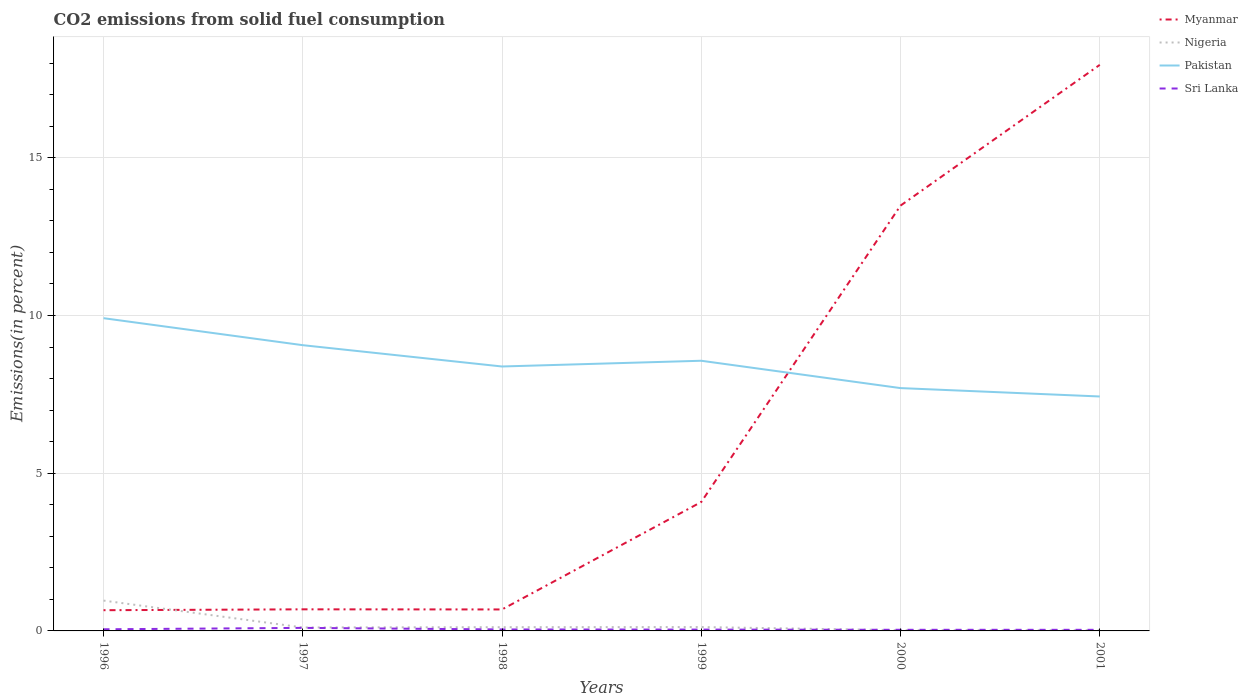How many different coloured lines are there?
Ensure brevity in your answer.  4. Across all years, what is the maximum total CO2 emitted in Nigeria?
Your answer should be very brief. 0.02. In which year was the total CO2 emitted in Sri Lanka maximum?
Your answer should be compact. 2001. What is the total total CO2 emitted in Pakistan in the graph?
Your answer should be compact. 2.22. What is the difference between the highest and the second highest total CO2 emitted in Myanmar?
Your answer should be very brief. 17.29. What is the difference between the highest and the lowest total CO2 emitted in Pakistan?
Your response must be concise. 3. How many lines are there?
Keep it short and to the point. 4. Are the values on the major ticks of Y-axis written in scientific E-notation?
Offer a terse response. No. Does the graph contain any zero values?
Make the answer very short. No. Does the graph contain grids?
Make the answer very short. Yes. Where does the legend appear in the graph?
Your response must be concise. Top right. How are the legend labels stacked?
Keep it short and to the point. Vertical. What is the title of the graph?
Keep it short and to the point. CO2 emissions from solid fuel consumption. What is the label or title of the Y-axis?
Offer a terse response. Emissions(in percent). What is the Emissions(in percent) of Myanmar in 1996?
Keep it short and to the point. 0.66. What is the Emissions(in percent) in Nigeria in 1996?
Make the answer very short. 0.96. What is the Emissions(in percent) in Pakistan in 1996?
Make the answer very short. 9.92. What is the Emissions(in percent) in Sri Lanka in 1996?
Offer a terse response. 0.05. What is the Emissions(in percent) of Myanmar in 1997?
Your answer should be compact. 0.68. What is the Emissions(in percent) in Nigeria in 1997?
Make the answer very short. 0.11. What is the Emissions(in percent) of Pakistan in 1997?
Offer a very short reply. 9.06. What is the Emissions(in percent) in Sri Lanka in 1997?
Keep it short and to the point. 0.1. What is the Emissions(in percent) of Myanmar in 1998?
Your answer should be very brief. 0.68. What is the Emissions(in percent) of Nigeria in 1998?
Provide a short and direct response. 0.12. What is the Emissions(in percent) in Pakistan in 1998?
Offer a terse response. 8.38. What is the Emissions(in percent) in Sri Lanka in 1998?
Offer a terse response. 0.05. What is the Emissions(in percent) of Myanmar in 1999?
Your response must be concise. 4.09. What is the Emissions(in percent) in Nigeria in 1999?
Your answer should be compact. 0.12. What is the Emissions(in percent) in Pakistan in 1999?
Make the answer very short. 8.57. What is the Emissions(in percent) in Sri Lanka in 1999?
Give a very brief answer. 0.04. What is the Emissions(in percent) of Myanmar in 2000?
Ensure brevity in your answer.  13.49. What is the Emissions(in percent) in Nigeria in 2000?
Keep it short and to the point. 0.02. What is the Emissions(in percent) of Pakistan in 2000?
Offer a terse response. 7.7. What is the Emissions(in percent) of Sri Lanka in 2000?
Ensure brevity in your answer.  0.04. What is the Emissions(in percent) of Myanmar in 2001?
Your answer should be very brief. 17.95. What is the Emissions(in percent) in Nigeria in 2001?
Your response must be concise. 0.02. What is the Emissions(in percent) of Pakistan in 2001?
Your answer should be very brief. 7.43. What is the Emissions(in percent) of Sri Lanka in 2001?
Give a very brief answer. 0.04. Across all years, what is the maximum Emissions(in percent) of Myanmar?
Provide a succinct answer. 17.95. Across all years, what is the maximum Emissions(in percent) of Nigeria?
Keep it short and to the point. 0.96. Across all years, what is the maximum Emissions(in percent) in Pakistan?
Make the answer very short. 9.92. Across all years, what is the maximum Emissions(in percent) in Sri Lanka?
Provide a short and direct response. 0.1. Across all years, what is the minimum Emissions(in percent) of Myanmar?
Your answer should be compact. 0.66. Across all years, what is the minimum Emissions(in percent) of Nigeria?
Your response must be concise. 0.02. Across all years, what is the minimum Emissions(in percent) in Pakistan?
Your response must be concise. 7.43. Across all years, what is the minimum Emissions(in percent) of Sri Lanka?
Ensure brevity in your answer.  0.04. What is the total Emissions(in percent) of Myanmar in the graph?
Your answer should be very brief. 37.55. What is the total Emissions(in percent) in Nigeria in the graph?
Offer a terse response. 1.36. What is the total Emissions(in percent) in Pakistan in the graph?
Your answer should be compact. 51.06. What is the total Emissions(in percent) in Sri Lanka in the graph?
Give a very brief answer. 0.31. What is the difference between the Emissions(in percent) of Myanmar in 1996 and that in 1997?
Your answer should be very brief. -0.03. What is the difference between the Emissions(in percent) of Nigeria in 1996 and that in 1997?
Offer a very short reply. 0.85. What is the difference between the Emissions(in percent) in Pakistan in 1996 and that in 1997?
Make the answer very short. 0.86. What is the difference between the Emissions(in percent) in Sri Lanka in 1996 and that in 1997?
Keep it short and to the point. -0.04. What is the difference between the Emissions(in percent) of Myanmar in 1996 and that in 1998?
Offer a very short reply. -0.02. What is the difference between the Emissions(in percent) of Nigeria in 1996 and that in 1998?
Make the answer very short. 0.84. What is the difference between the Emissions(in percent) of Pakistan in 1996 and that in 1998?
Provide a succinct answer. 1.53. What is the difference between the Emissions(in percent) in Sri Lanka in 1996 and that in 1998?
Your response must be concise. 0.01. What is the difference between the Emissions(in percent) of Myanmar in 1996 and that in 1999?
Ensure brevity in your answer.  -3.43. What is the difference between the Emissions(in percent) of Nigeria in 1996 and that in 1999?
Your answer should be compact. 0.84. What is the difference between the Emissions(in percent) of Pakistan in 1996 and that in 1999?
Offer a very short reply. 1.35. What is the difference between the Emissions(in percent) in Sri Lanka in 1996 and that in 1999?
Ensure brevity in your answer.  0.01. What is the difference between the Emissions(in percent) in Myanmar in 1996 and that in 2000?
Provide a succinct answer. -12.83. What is the difference between the Emissions(in percent) in Nigeria in 1996 and that in 2000?
Your answer should be compact. 0.94. What is the difference between the Emissions(in percent) in Pakistan in 1996 and that in 2000?
Provide a short and direct response. 2.22. What is the difference between the Emissions(in percent) of Sri Lanka in 1996 and that in 2000?
Offer a very short reply. 0.02. What is the difference between the Emissions(in percent) in Myanmar in 1996 and that in 2001?
Your answer should be compact. -17.29. What is the difference between the Emissions(in percent) of Nigeria in 1996 and that in 2001?
Provide a short and direct response. 0.94. What is the difference between the Emissions(in percent) of Pakistan in 1996 and that in 2001?
Make the answer very short. 2.48. What is the difference between the Emissions(in percent) in Sri Lanka in 1996 and that in 2001?
Offer a very short reply. 0.02. What is the difference between the Emissions(in percent) in Myanmar in 1997 and that in 1998?
Your response must be concise. 0. What is the difference between the Emissions(in percent) in Nigeria in 1997 and that in 1998?
Your answer should be compact. -0.01. What is the difference between the Emissions(in percent) in Pakistan in 1997 and that in 1998?
Your answer should be very brief. 0.68. What is the difference between the Emissions(in percent) of Sri Lanka in 1997 and that in 1998?
Offer a very short reply. 0.05. What is the difference between the Emissions(in percent) of Myanmar in 1997 and that in 1999?
Give a very brief answer. -3.4. What is the difference between the Emissions(in percent) of Nigeria in 1997 and that in 1999?
Your response must be concise. -0.01. What is the difference between the Emissions(in percent) of Pakistan in 1997 and that in 1999?
Provide a succinct answer. 0.49. What is the difference between the Emissions(in percent) in Sri Lanka in 1997 and that in 1999?
Provide a succinct answer. 0.05. What is the difference between the Emissions(in percent) of Myanmar in 1997 and that in 2000?
Provide a short and direct response. -12.8. What is the difference between the Emissions(in percent) of Nigeria in 1997 and that in 2000?
Your answer should be compact. 0.09. What is the difference between the Emissions(in percent) of Pakistan in 1997 and that in 2000?
Offer a terse response. 1.36. What is the difference between the Emissions(in percent) of Sri Lanka in 1997 and that in 2000?
Your answer should be very brief. 0.06. What is the difference between the Emissions(in percent) in Myanmar in 1997 and that in 2001?
Your answer should be compact. -17.26. What is the difference between the Emissions(in percent) in Nigeria in 1997 and that in 2001?
Your answer should be very brief. 0.09. What is the difference between the Emissions(in percent) in Pakistan in 1997 and that in 2001?
Give a very brief answer. 1.63. What is the difference between the Emissions(in percent) of Sri Lanka in 1997 and that in 2001?
Provide a short and direct response. 0.06. What is the difference between the Emissions(in percent) in Myanmar in 1998 and that in 1999?
Make the answer very short. -3.41. What is the difference between the Emissions(in percent) in Nigeria in 1998 and that in 1999?
Provide a succinct answer. -0. What is the difference between the Emissions(in percent) of Pakistan in 1998 and that in 1999?
Your answer should be compact. -0.18. What is the difference between the Emissions(in percent) of Sri Lanka in 1998 and that in 1999?
Offer a terse response. 0. What is the difference between the Emissions(in percent) of Myanmar in 1998 and that in 2000?
Offer a terse response. -12.81. What is the difference between the Emissions(in percent) in Nigeria in 1998 and that in 2000?
Ensure brevity in your answer.  0.1. What is the difference between the Emissions(in percent) of Pakistan in 1998 and that in 2000?
Your answer should be very brief. 0.69. What is the difference between the Emissions(in percent) in Sri Lanka in 1998 and that in 2000?
Keep it short and to the point. 0.01. What is the difference between the Emissions(in percent) in Myanmar in 1998 and that in 2001?
Your answer should be very brief. -17.27. What is the difference between the Emissions(in percent) of Nigeria in 1998 and that in 2001?
Make the answer very short. 0.1. What is the difference between the Emissions(in percent) in Pakistan in 1998 and that in 2001?
Your answer should be very brief. 0.95. What is the difference between the Emissions(in percent) of Sri Lanka in 1998 and that in 2001?
Provide a succinct answer. 0.01. What is the difference between the Emissions(in percent) in Myanmar in 1999 and that in 2000?
Provide a succinct answer. -9.4. What is the difference between the Emissions(in percent) of Nigeria in 1999 and that in 2000?
Your answer should be compact. 0.1. What is the difference between the Emissions(in percent) of Pakistan in 1999 and that in 2000?
Ensure brevity in your answer.  0.87. What is the difference between the Emissions(in percent) of Sri Lanka in 1999 and that in 2000?
Your response must be concise. 0.01. What is the difference between the Emissions(in percent) of Myanmar in 1999 and that in 2001?
Make the answer very short. -13.86. What is the difference between the Emissions(in percent) of Nigeria in 1999 and that in 2001?
Offer a very short reply. 0.1. What is the difference between the Emissions(in percent) in Pakistan in 1999 and that in 2001?
Provide a succinct answer. 1.13. What is the difference between the Emissions(in percent) in Sri Lanka in 1999 and that in 2001?
Your response must be concise. 0.01. What is the difference between the Emissions(in percent) in Myanmar in 2000 and that in 2001?
Provide a short and direct response. -4.46. What is the difference between the Emissions(in percent) of Nigeria in 2000 and that in 2001?
Make the answer very short. 0. What is the difference between the Emissions(in percent) of Pakistan in 2000 and that in 2001?
Provide a short and direct response. 0.27. What is the difference between the Emissions(in percent) of Sri Lanka in 2000 and that in 2001?
Your answer should be very brief. 0. What is the difference between the Emissions(in percent) in Myanmar in 1996 and the Emissions(in percent) in Nigeria in 1997?
Provide a short and direct response. 0.55. What is the difference between the Emissions(in percent) of Myanmar in 1996 and the Emissions(in percent) of Pakistan in 1997?
Your response must be concise. -8.4. What is the difference between the Emissions(in percent) of Myanmar in 1996 and the Emissions(in percent) of Sri Lanka in 1997?
Offer a very short reply. 0.56. What is the difference between the Emissions(in percent) of Nigeria in 1996 and the Emissions(in percent) of Pakistan in 1997?
Provide a succinct answer. -8.1. What is the difference between the Emissions(in percent) of Nigeria in 1996 and the Emissions(in percent) of Sri Lanka in 1997?
Your response must be concise. 0.87. What is the difference between the Emissions(in percent) of Pakistan in 1996 and the Emissions(in percent) of Sri Lanka in 1997?
Offer a very short reply. 9.82. What is the difference between the Emissions(in percent) in Myanmar in 1996 and the Emissions(in percent) in Nigeria in 1998?
Your answer should be compact. 0.54. What is the difference between the Emissions(in percent) of Myanmar in 1996 and the Emissions(in percent) of Pakistan in 1998?
Give a very brief answer. -7.73. What is the difference between the Emissions(in percent) of Myanmar in 1996 and the Emissions(in percent) of Sri Lanka in 1998?
Offer a terse response. 0.61. What is the difference between the Emissions(in percent) in Nigeria in 1996 and the Emissions(in percent) in Pakistan in 1998?
Offer a very short reply. -7.42. What is the difference between the Emissions(in percent) of Nigeria in 1996 and the Emissions(in percent) of Sri Lanka in 1998?
Give a very brief answer. 0.91. What is the difference between the Emissions(in percent) in Pakistan in 1996 and the Emissions(in percent) in Sri Lanka in 1998?
Keep it short and to the point. 9.87. What is the difference between the Emissions(in percent) in Myanmar in 1996 and the Emissions(in percent) in Nigeria in 1999?
Give a very brief answer. 0.53. What is the difference between the Emissions(in percent) in Myanmar in 1996 and the Emissions(in percent) in Pakistan in 1999?
Your response must be concise. -7.91. What is the difference between the Emissions(in percent) of Myanmar in 1996 and the Emissions(in percent) of Sri Lanka in 1999?
Ensure brevity in your answer.  0.61. What is the difference between the Emissions(in percent) of Nigeria in 1996 and the Emissions(in percent) of Pakistan in 1999?
Provide a succinct answer. -7.6. What is the difference between the Emissions(in percent) of Nigeria in 1996 and the Emissions(in percent) of Sri Lanka in 1999?
Your answer should be very brief. 0.92. What is the difference between the Emissions(in percent) in Pakistan in 1996 and the Emissions(in percent) in Sri Lanka in 1999?
Your answer should be very brief. 9.87. What is the difference between the Emissions(in percent) in Myanmar in 1996 and the Emissions(in percent) in Nigeria in 2000?
Offer a terse response. 0.63. What is the difference between the Emissions(in percent) in Myanmar in 1996 and the Emissions(in percent) in Pakistan in 2000?
Ensure brevity in your answer.  -7.04. What is the difference between the Emissions(in percent) of Myanmar in 1996 and the Emissions(in percent) of Sri Lanka in 2000?
Provide a short and direct response. 0.62. What is the difference between the Emissions(in percent) of Nigeria in 1996 and the Emissions(in percent) of Pakistan in 2000?
Your answer should be very brief. -6.74. What is the difference between the Emissions(in percent) of Nigeria in 1996 and the Emissions(in percent) of Sri Lanka in 2000?
Give a very brief answer. 0.93. What is the difference between the Emissions(in percent) in Pakistan in 1996 and the Emissions(in percent) in Sri Lanka in 2000?
Your answer should be very brief. 9.88. What is the difference between the Emissions(in percent) in Myanmar in 1996 and the Emissions(in percent) in Nigeria in 2001?
Your response must be concise. 0.63. What is the difference between the Emissions(in percent) in Myanmar in 1996 and the Emissions(in percent) in Pakistan in 2001?
Your answer should be compact. -6.78. What is the difference between the Emissions(in percent) of Myanmar in 1996 and the Emissions(in percent) of Sri Lanka in 2001?
Offer a very short reply. 0.62. What is the difference between the Emissions(in percent) in Nigeria in 1996 and the Emissions(in percent) in Pakistan in 2001?
Keep it short and to the point. -6.47. What is the difference between the Emissions(in percent) of Nigeria in 1996 and the Emissions(in percent) of Sri Lanka in 2001?
Provide a short and direct response. 0.93. What is the difference between the Emissions(in percent) in Pakistan in 1996 and the Emissions(in percent) in Sri Lanka in 2001?
Provide a succinct answer. 9.88. What is the difference between the Emissions(in percent) of Myanmar in 1997 and the Emissions(in percent) of Nigeria in 1998?
Ensure brevity in your answer.  0.57. What is the difference between the Emissions(in percent) of Myanmar in 1997 and the Emissions(in percent) of Pakistan in 1998?
Keep it short and to the point. -7.7. What is the difference between the Emissions(in percent) of Myanmar in 1997 and the Emissions(in percent) of Sri Lanka in 1998?
Your response must be concise. 0.64. What is the difference between the Emissions(in percent) of Nigeria in 1997 and the Emissions(in percent) of Pakistan in 1998?
Provide a succinct answer. -8.27. What is the difference between the Emissions(in percent) of Nigeria in 1997 and the Emissions(in percent) of Sri Lanka in 1998?
Make the answer very short. 0.06. What is the difference between the Emissions(in percent) in Pakistan in 1997 and the Emissions(in percent) in Sri Lanka in 1998?
Keep it short and to the point. 9.01. What is the difference between the Emissions(in percent) in Myanmar in 1997 and the Emissions(in percent) in Nigeria in 1999?
Keep it short and to the point. 0.56. What is the difference between the Emissions(in percent) in Myanmar in 1997 and the Emissions(in percent) in Pakistan in 1999?
Give a very brief answer. -7.88. What is the difference between the Emissions(in percent) in Myanmar in 1997 and the Emissions(in percent) in Sri Lanka in 1999?
Ensure brevity in your answer.  0.64. What is the difference between the Emissions(in percent) of Nigeria in 1997 and the Emissions(in percent) of Pakistan in 1999?
Offer a very short reply. -8.46. What is the difference between the Emissions(in percent) in Nigeria in 1997 and the Emissions(in percent) in Sri Lanka in 1999?
Your answer should be very brief. 0.07. What is the difference between the Emissions(in percent) in Pakistan in 1997 and the Emissions(in percent) in Sri Lanka in 1999?
Your response must be concise. 9.02. What is the difference between the Emissions(in percent) in Myanmar in 1997 and the Emissions(in percent) in Nigeria in 2000?
Provide a succinct answer. 0.66. What is the difference between the Emissions(in percent) of Myanmar in 1997 and the Emissions(in percent) of Pakistan in 2000?
Ensure brevity in your answer.  -7.01. What is the difference between the Emissions(in percent) of Myanmar in 1997 and the Emissions(in percent) of Sri Lanka in 2000?
Make the answer very short. 0.65. What is the difference between the Emissions(in percent) in Nigeria in 1997 and the Emissions(in percent) in Pakistan in 2000?
Ensure brevity in your answer.  -7.59. What is the difference between the Emissions(in percent) of Nigeria in 1997 and the Emissions(in percent) of Sri Lanka in 2000?
Ensure brevity in your answer.  0.07. What is the difference between the Emissions(in percent) of Pakistan in 1997 and the Emissions(in percent) of Sri Lanka in 2000?
Your answer should be very brief. 9.02. What is the difference between the Emissions(in percent) in Myanmar in 1997 and the Emissions(in percent) in Nigeria in 2001?
Offer a terse response. 0.66. What is the difference between the Emissions(in percent) of Myanmar in 1997 and the Emissions(in percent) of Pakistan in 2001?
Provide a short and direct response. -6.75. What is the difference between the Emissions(in percent) in Myanmar in 1997 and the Emissions(in percent) in Sri Lanka in 2001?
Provide a short and direct response. 0.65. What is the difference between the Emissions(in percent) of Nigeria in 1997 and the Emissions(in percent) of Pakistan in 2001?
Keep it short and to the point. -7.32. What is the difference between the Emissions(in percent) in Nigeria in 1997 and the Emissions(in percent) in Sri Lanka in 2001?
Offer a very short reply. 0.07. What is the difference between the Emissions(in percent) in Pakistan in 1997 and the Emissions(in percent) in Sri Lanka in 2001?
Provide a succinct answer. 9.02. What is the difference between the Emissions(in percent) of Myanmar in 1998 and the Emissions(in percent) of Nigeria in 1999?
Offer a terse response. 0.56. What is the difference between the Emissions(in percent) of Myanmar in 1998 and the Emissions(in percent) of Pakistan in 1999?
Provide a succinct answer. -7.89. What is the difference between the Emissions(in percent) of Myanmar in 1998 and the Emissions(in percent) of Sri Lanka in 1999?
Provide a succinct answer. 0.64. What is the difference between the Emissions(in percent) in Nigeria in 1998 and the Emissions(in percent) in Pakistan in 1999?
Your answer should be very brief. -8.45. What is the difference between the Emissions(in percent) of Nigeria in 1998 and the Emissions(in percent) of Sri Lanka in 1999?
Your response must be concise. 0.08. What is the difference between the Emissions(in percent) of Pakistan in 1998 and the Emissions(in percent) of Sri Lanka in 1999?
Your answer should be very brief. 8.34. What is the difference between the Emissions(in percent) in Myanmar in 1998 and the Emissions(in percent) in Nigeria in 2000?
Your answer should be very brief. 0.66. What is the difference between the Emissions(in percent) of Myanmar in 1998 and the Emissions(in percent) of Pakistan in 2000?
Offer a very short reply. -7.02. What is the difference between the Emissions(in percent) in Myanmar in 1998 and the Emissions(in percent) in Sri Lanka in 2000?
Your answer should be compact. 0.65. What is the difference between the Emissions(in percent) of Nigeria in 1998 and the Emissions(in percent) of Pakistan in 2000?
Make the answer very short. -7.58. What is the difference between the Emissions(in percent) in Nigeria in 1998 and the Emissions(in percent) in Sri Lanka in 2000?
Your answer should be very brief. 0.08. What is the difference between the Emissions(in percent) in Pakistan in 1998 and the Emissions(in percent) in Sri Lanka in 2000?
Make the answer very short. 8.35. What is the difference between the Emissions(in percent) in Myanmar in 1998 and the Emissions(in percent) in Nigeria in 2001?
Offer a terse response. 0.66. What is the difference between the Emissions(in percent) of Myanmar in 1998 and the Emissions(in percent) of Pakistan in 2001?
Ensure brevity in your answer.  -6.75. What is the difference between the Emissions(in percent) in Myanmar in 1998 and the Emissions(in percent) in Sri Lanka in 2001?
Offer a terse response. 0.65. What is the difference between the Emissions(in percent) in Nigeria in 1998 and the Emissions(in percent) in Pakistan in 2001?
Offer a very short reply. -7.31. What is the difference between the Emissions(in percent) in Nigeria in 1998 and the Emissions(in percent) in Sri Lanka in 2001?
Give a very brief answer. 0.08. What is the difference between the Emissions(in percent) in Pakistan in 1998 and the Emissions(in percent) in Sri Lanka in 2001?
Keep it short and to the point. 8.35. What is the difference between the Emissions(in percent) of Myanmar in 1999 and the Emissions(in percent) of Nigeria in 2000?
Provide a short and direct response. 4.07. What is the difference between the Emissions(in percent) of Myanmar in 1999 and the Emissions(in percent) of Pakistan in 2000?
Offer a very short reply. -3.61. What is the difference between the Emissions(in percent) of Myanmar in 1999 and the Emissions(in percent) of Sri Lanka in 2000?
Offer a very short reply. 4.05. What is the difference between the Emissions(in percent) in Nigeria in 1999 and the Emissions(in percent) in Pakistan in 2000?
Offer a terse response. -7.58. What is the difference between the Emissions(in percent) in Nigeria in 1999 and the Emissions(in percent) in Sri Lanka in 2000?
Make the answer very short. 0.09. What is the difference between the Emissions(in percent) of Pakistan in 1999 and the Emissions(in percent) of Sri Lanka in 2000?
Provide a succinct answer. 8.53. What is the difference between the Emissions(in percent) in Myanmar in 1999 and the Emissions(in percent) in Nigeria in 2001?
Provide a short and direct response. 4.07. What is the difference between the Emissions(in percent) in Myanmar in 1999 and the Emissions(in percent) in Pakistan in 2001?
Keep it short and to the point. -3.35. What is the difference between the Emissions(in percent) of Myanmar in 1999 and the Emissions(in percent) of Sri Lanka in 2001?
Your answer should be compact. 4.05. What is the difference between the Emissions(in percent) in Nigeria in 1999 and the Emissions(in percent) in Pakistan in 2001?
Make the answer very short. -7.31. What is the difference between the Emissions(in percent) in Nigeria in 1999 and the Emissions(in percent) in Sri Lanka in 2001?
Keep it short and to the point. 0.09. What is the difference between the Emissions(in percent) of Pakistan in 1999 and the Emissions(in percent) of Sri Lanka in 2001?
Give a very brief answer. 8.53. What is the difference between the Emissions(in percent) in Myanmar in 2000 and the Emissions(in percent) in Nigeria in 2001?
Provide a succinct answer. 13.46. What is the difference between the Emissions(in percent) in Myanmar in 2000 and the Emissions(in percent) in Pakistan in 2001?
Your answer should be compact. 6.05. What is the difference between the Emissions(in percent) in Myanmar in 2000 and the Emissions(in percent) in Sri Lanka in 2001?
Provide a short and direct response. 13.45. What is the difference between the Emissions(in percent) of Nigeria in 2000 and the Emissions(in percent) of Pakistan in 2001?
Your answer should be compact. -7.41. What is the difference between the Emissions(in percent) in Nigeria in 2000 and the Emissions(in percent) in Sri Lanka in 2001?
Offer a very short reply. -0.01. What is the difference between the Emissions(in percent) in Pakistan in 2000 and the Emissions(in percent) in Sri Lanka in 2001?
Your response must be concise. 7.66. What is the average Emissions(in percent) of Myanmar per year?
Provide a short and direct response. 6.26. What is the average Emissions(in percent) in Nigeria per year?
Your answer should be very brief. 0.23. What is the average Emissions(in percent) of Pakistan per year?
Give a very brief answer. 8.51. What is the average Emissions(in percent) in Sri Lanka per year?
Keep it short and to the point. 0.05. In the year 1996, what is the difference between the Emissions(in percent) of Myanmar and Emissions(in percent) of Nigeria?
Offer a terse response. -0.3. In the year 1996, what is the difference between the Emissions(in percent) of Myanmar and Emissions(in percent) of Pakistan?
Provide a short and direct response. -9.26. In the year 1996, what is the difference between the Emissions(in percent) of Myanmar and Emissions(in percent) of Sri Lanka?
Offer a very short reply. 0.6. In the year 1996, what is the difference between the Emissions(in percent) of Nigeria and Emissions(in percent) of Pakistan?
Make the answer very short. -8.95. In the year 1996, what is the difference between the Emissions(in percent) in Nigeria and Emissions(in percent) in Sri Lanka?
Your answer should be very brief. 0.91. In the year 1996, what is the difference between the Emissions(in percent) of Pakistan and Emissions(in percent) of Sri Lanka?
Make the answer very short. 9.86. In the year 1997, what is the difference between the Emissions(in percent) in Myanmar and Emissions(in percent) in Nigeria?
Your answer should be very brief. 0.58. In the year 1997, what is the difference between the Emissions(in percent) of Myanmar and Emissions(in percent) of Pakistan?
Provide a short and direct response. -8.38. In the year 1997, what is the difference between the Emissions(in percent) in Myanmar and Emissions(in percent) in Sri Lanka?
Your answer should be very brief. 0.59. In the year 1997, what is the difference between the Emissions(in percent) in Nigeria and Emissions(in percent) in Pakistan?
Your response must be concise. -8.95. In the year 1997, what is the difference between the Emissions(in percent) in Nigeria and Emissions(in percent) in Sri Lanka?
Offer a very short reply. 0.01. In the year 1997, what is the difference between the Emissions(in percent) in Pakistan and Emissions(in percent) in Sri Lanka?
Keep it short and to the point. 8.96. In the year 1998, what is the difference between the Emissions(in percent) of Myanmar and Emissions(in percent) of Nigeria?
Your answer should be very brief. 0.56. In the year 1998, what is the difference between the Emissions(in percent) of Myanmar and Emissions(in percent) of Pakistan?
Offer a very short reply. -7.7. In the year 1998, what is the difference between the Emissions(in percent) in Myanmar and Emissions(in percent) in Sri Lanka?
Offer a very short reply. 0.63. In the year 1998, what is the difference between the Emissions(in percent) of Nigeria and Emissions(in percent) of Pakistan?
Your response must be concise. -8.27. In the year 1998, what is the difference between the Emissions(in percent) in Nigeria and Emissions(in percent) in Sri Lanka?
Give a very brief answer. 0.07. In the year 1998, what is the difference between the Emissions(in percent) of Pakistan and Emissions(in percent) of Sri Lanka?
Offer a terse response. 8.34. In the year 1999, what is the difference between the Emissions(in percent) of Myanmar and Emissions(in percent) of Nigeria?
Offer a very short reply. 3.97. In the year 1999, what is the difference between the Emissions(in percent) of Myanmar and Emissions(in percent) of Pakistan?
Keep it short and to the point. -4.48. In the year 1999, what is the difference between the Emissions(in percent) in Myanmar and Emissions(in percent) in Sri Lanka?
Give a very brief answer. 4.05. In the year 1999, what is the difference between the Emissions(in percent) of Nigeria and Emissions(in percent) of Pakistan?
Your answer should be very brief. -8.44. In the year 1999, what is the difference between the Emissions(in percent) of Nigeria and Emissions(in percent) of Sri Lanka?
Offer a very short reply. 0.08. In the year 1999, what is the difference between the Emissions(in percent) in Pakistan and Emissions(in percent) in Sri Lanka?
Your answer should be very brief. 8.52. In the year 2000, what is the difference between the Emissions(in percent) of Myanmar and Emissions(in percent) of Nigeria?
Give a very brief answer. 13.46. In the year 2000, what is the difference between the Emissions(in percent) in Myanmar and Emissions(in percent) in Pakistan?
Offer a terse response. 5.79. In the year 2000, what is the difference between the Emissions(in percent) of Myanmar and Emissions(in percent) of Sri Lanka?
Make the answer very short. 13.45. In the year 2000, what is the difference between the Emissions(in percent) of Nigeria and Emissions(in percent) of Pakistan?
Ensure brevity in your answer.  -7.68. In the year 2000, what is the difference between the Emissions(in percent) of Nigeria and Emissions(in percent) of Sri Lanka?
Provide a short and direct response. -0.01. In the year 2000, what is the difference between the Emissions(in percent) in Pakistan and Emissions(in percent) in Sri Lanka?
Your response must be concise. 7.66. In the year 2001, what is the difference between the Emissions(in percent) in Myanmar and Emissions(in percent) in Nigeria?
Ensure brevity in your answer.  17.93. In the year 2001, what is the difference between the Emissions(in percent) in Myanmar and Emissions(in percent) in Pakistan?
Provide a succinct answer. 10.52. In the year 2001, what is the difference between the Emissions(in percent) in Myanmar and Emissions(in percent) in Sri Lanka?
Your response must be concise. 17.91. In the year 2001, what is the difference between the Emissions(in percent) of Nigeria and Emissions(in percent) of Pakistan?
Keep it short and to the point. -7.41. In the year 2001, what is the difference between the Emissions(in percent) in Nigeria and Emissions(in percent) in Sri Lanka?
Offer a very short reply. -0.01. In the year 2001, what is the difference between the Emissions(in percent) in Pakistan and Emissions(in percent) in Sri Lanka?
Your answer should be compact. 7.4. What is the ratio of the Emissions(in percent) of Myanmar in 1996 to that in 1997?
Offer a very short reply. 0.96. What is the ratio of the Emissions(in percent) in Nigeria in 1996 to that in 1997?
Offer a very short reply. 8.78. What is the ratio of the Emissions(in percent) of Pakistan in 1996 to that in 1997?
Your answer should be very brief. 1.09. What is the ratio of the Emissions(in percent) in Sri Lanka in 1996 to that in 1997?
Your answer should be very brief. 0.54. What is the ratio of the Emissions(in percent) of Myanmar in 1996 to that in 1998?
Ensure brevity in your answer.  0.96. What is the ratio of the Emissions(in percent) of Nigeria in 1996 to that in 1998?
Provide a succinct answer. 8.11. What is the ratio of the Emissions(in percent) in Pakistan in 1996 to that in 1998?
Provide a succinct answer. 1.18. What is the ratio of the Emissions(in percent) of Sri Lanka in 1996 to that in 1998?
Offer a terse response. 1.11. What is the ratio of the Emissions(in percent) of Myanmar in 1996 to that in 1999?
Make the answer very short. 0.16. What is the ratio of the Emissions(in percent) of Nigeria in 1996 to that in 1999?
Offer a very short reply. 7.83. What is the ratio of the Emissions(in percent) of Pakistan in 1996 to that in 1999?
Offer a very short reply. 1.16. What is the ratio of the Emissions(in percent) of Sri Lanka in 1996 to that in 1999?
Make the answer very short. 1.22. What is the ratio of the Emissions(in percent) of Myanmar in 1996 to that in 2000?
Your response must be concise. 0.05. What is the ratio of the Emissions(in percent) in Nigeria in 1996 to that in 2000?
Offer a very short reply. 41.53. What is the ratio of the Emissions(in percent) in Pakistan in 1996 to that in 2000?
Provide a succinct answer. 1.29. What is the ratio of the Emissions(in percent) in Sri Lanka in 1996 to that in 2000?
Ensure brevity in your answer.  1.45. What is the ratio of the Emissions(in percent) of Myanmar in 1996 to that in 2001?
Offer a terse response. 0.04. What is the ratio of the Emissions(in percent) of Nigeria in 1996 to that in 2001?
Ensure brevity in your answer.  43.72. What is the ratio of the Emissions(in percent) in Pakistan in 1996 to that in 2001?
Give a very brief answer. 1.33. What is the ratio of the Emissions(in percent) in Sri Lanka in 1996 to that in 2001?
Provide a succinct answer. 1.48. What is the ratio of the Emissions(in percent) in Myanmar in 1997 to that in 1998?
Provide a succinct answer. 1.01. What is the ratio of the Emissions(in percent) of Nigeria in 1997 to that in 1998?
Make the answer very short. 0.92. What is the ratio of the Emissions(in percent) in Pakistan in 1997 to that in 1998?
Your answer should be compact. 1.08. What is the ratio of the Emissions(in percent) of Sri Lanka in 1997 to that in 1998?
Give a very brief answer. 2.05. What is the ratio of the Emissions(in percent) of Myanmar in 1997 to that in 1999?
Provide a short and direct response. 0.17. What is the ratio of the Emissions(in percent) in Nigeria in 1997 to that in 1999?
Make the answer very short. 0.89. What is the ratio of the Emissions(in percent) in Pakistan in 1997 to that in 1999?
Make the answer very short. 1.06. What is the ratio of the Emissions(in percent) in Sri Lanka in 1997 to that in 1999?
Provide a succinct answer. 2.26. What is the ratio of the Emissions(in percent) of Myanmar in 1997 to that in 2000?
Offer a terse response. 0.05. What is the ratio of the Emissions(in percent) of Nigeria in 1997 to that in 2000?
Provide a short and direct response. 4.73. What is the ratio of the Emissions(in percent) in Pakistan in 1997 to that in 2000?
Give a very brief answer. 1.18. What is the ratio of the Emissions(in percent) in Sri Lanka in 1997 to that in 2000?
Ensure brevity in your answer.  2.69. What is the ratio of the Emissions(in percent) of Myanmar in 1997 to that in 2001?
Provide a succinct answer. 0.04. What is the ratio of the Emissions(in percent) in Nigeria in 1997 to that in 2001?
Provide a short and direct response. 4.98. What is the ratio of the Emissions(in percent) of Pakistan in 1997 to that in 2001?
Ensure brevity in your answer.  1.22. What is the ratio of the Emissions(in percent) in Sri Lanka in 1997 to that in 2001?
Keep it short and to the point. 2.74. What is the ratio of the Emissions(in percent) of Myanmar in 1998 to that in 1999?
Keep it short and to the point. 0.17. What is the ratio of the Emissions(in percent) of Nigeria in 1998 to that in 1999?
Your answer should be very brief. 0.97. What is the ratio of the Emissions(in percent) of Pakistan in 1998 to that in 1999?
Ensure brevity in your answer.  0.98. What is the ratio of the Emissions(in percent) in Sri Lanka in 1998 to that in 1999?
Your answer should be very brief. 1.1. What is the ratio of the Emissions(in percent) of Myanmar in 1998 to that in 2000?
Ensure brevity in your answer.  0.05. What is the ratio of the Emissions(in percent) in Nigeria in 1998 to that in 2000?
Make the answer very short. 5.12. What is the ratio of the Emissions(in percent) of Pakistan in 1998 to that in 2000?
Give a very brief answer. 1.09. What is the ratio of the Emissions(in percent) of Sri Lanka in 1998 to that in 2000?
Make the answer very short. 1.31. What is the ratio of the Emissions(in percent) of Myanmar in 1998 to that in 2001?
Provide a succinct answer. 0.04. What is the ratio of the Emissions(in percent) in Nigeria in 1998 to that in 2001?
Offer a terse response. 5.39. What is the ratio of the Emissions(in percent) in Pakistan in 1998 to that in 2001?
Keep it short and to the point. 1.13. What is the ratio of the Emissions(in percent) of Sri Lanka in 1998 to that in 2001?
Your answer should be very brief. 1.33. What is the ratio of the Emissions(in percent) of Myanmar in 1999 to that in 2000?
Offer a very short reply. 0.3. What is the ratio of the Emissions(in percent) in Nigeria in 1999 to that in 2000?
Provide a short and direct response. 5.3. What is the ratio of the Emissions(in percent) in Pakistan in 1999 to that in 2000?
Offer a very short reply. 1.11. What is the ratio of the Emissions(in percent) of Sri Lanka in 1999 to that in 2000?
Offer a terse response. 1.19. What is the ratio of the Emissions(in percent) in Myanmar in 1999 to that in 2001?
Your answer should be very brief. 0.23. What is the ratio of the Emissions(in percent) of Nigeria in 1999 to that in 2001?
Offer a very short reply. 5.58. What is the ratio of the Emissions(in percent) of Pakistan in 1999 to that in 2001?
Offer a very short reply. 1.15. What is the ratio of the Emissions(in percent) in Sri Lanka in 1999 to that in 2001?
Make the answer very short. 1.21. What is the ratio of the Emissions(in percent) of Myanmar in 2000 to that in 2001?
Your response must be concise. 0.75. What is the ratio of the Emissions(in percent) in Nigeria in 2000 to that in 2001?
Make the answer very short. 1.05. What is the ratio of the Emissions(in percent) of Pakistan in 2000 to that in 2001?
Offer a very short reply. 1.04. What is the ratio of the Emissions(in percent) of Sri Lanka in 2000 to that in 2001?
Provide a short and direct response. 1.02. What is the difference between the highest and the second highest Emissions(in percent) of Myanmar?
Your answer should be compact. 4.46. What is the difference between the highest and the second highest Emissions(in percent) of Nigeria?
Your answer should be very brief. 0.84. What is the difference between the highest and the second highest Emissions(in percent) in Pakistan?
Provide a short and direct response. 0.86. What is the difference between the highest and the second highest Emissions(in percent) in Sri Lanka?
Make the answer very short. 0.04. What is the difference between the highest and the lowest Emissions(in percent) in Myanmar?
Offer a terse response. 17.29. What is the difference between the highest and the lowest Emissions(in percent) in Nigeria?
Your response must be concise. 0.94. What is the difference between the highest and the lowest Emissions(in percent) of Pakistan?
Your response must be concise. 2.48. What is the difference between the highest and the lowest Emissions(in percent) of Sri Lanka?
Offer a terse response. 0.06. 